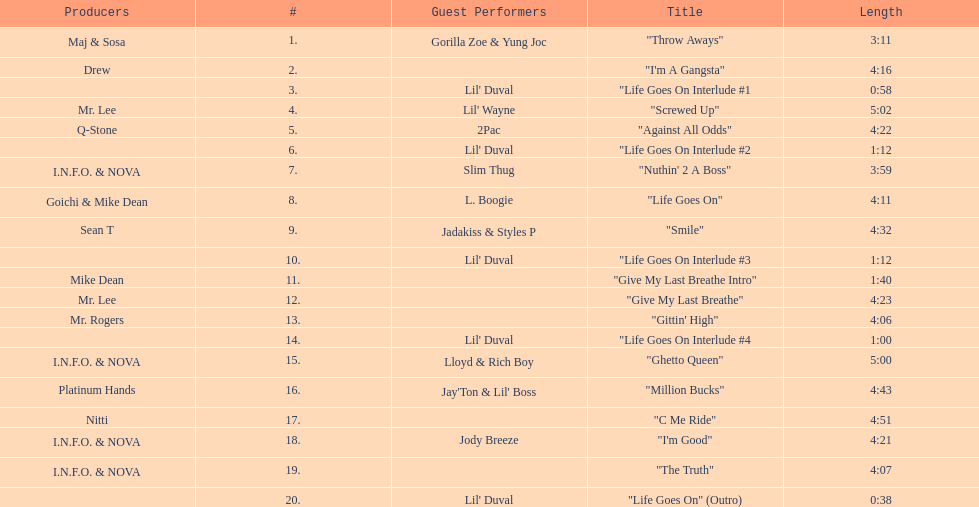What is the first track featuring lil' duval? "Life Goes On Interlude #1. 